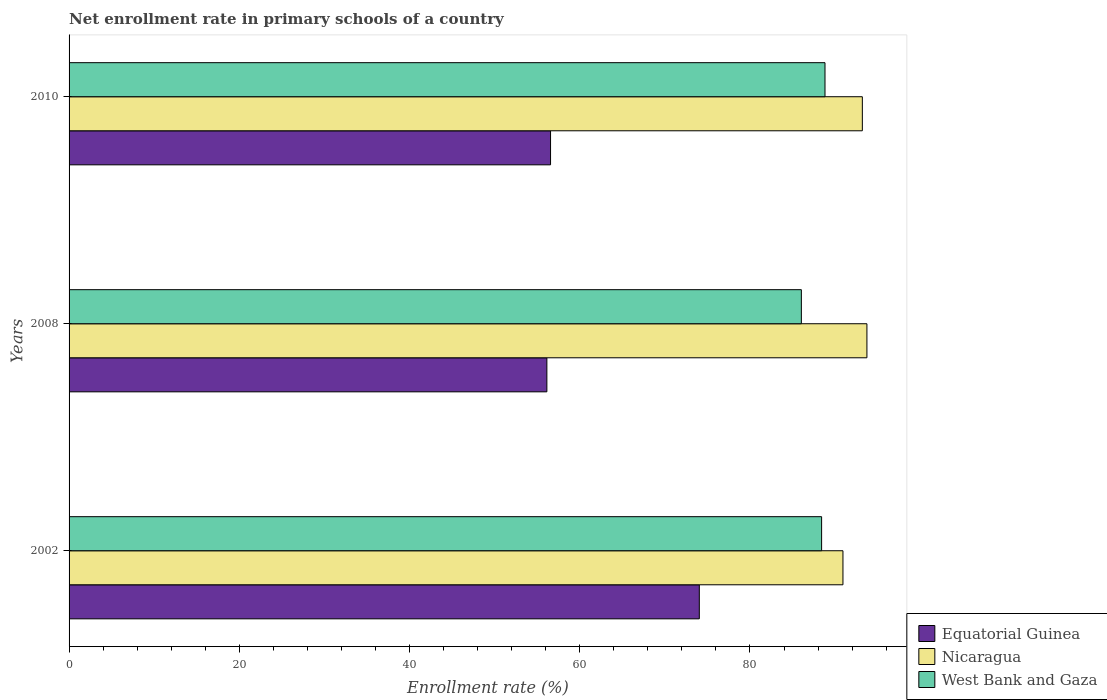How many groups of bars are there?
Keep it short and to the point. 3. How many bars are there on the 1st tick from the bottom?
Your answer should be very brief. 3. What is the enrollment rate in primary schools in Equatorial Guinea in 2010?
Provide a short and direct response. 56.57. Across all years, what is the maximum enrollment rate in primary schools in West Bank and Gaza?
Provide a succinct answer. 88.82. Across all years, what is the minimum enrollment rate in primary schools in Nicaragua?
Make the answer very short. 90.92. What is the total enrollment rate in primary schools in Equatorial Guinea in the graph?
Offer a terse response. 186.75. What is the difference between the enrollment rate in primary schools in Equatorial Guinea in 2002 and that in 2008?
Keep it short and to the point. 17.91. What is the difference between the enrollment rate in primary schools in Equatorial Guinea in 2010 and the enrollment rate in primary schools in Nicaragua in 2008?
Offer a very short reply. -37.17. What is the average enrollment rate in primary schools in Equatorial Guinea per year?
Your answer should be compact. 62.25. In the year 2008, what is the difference between the enrollment rate in primary schools in West Bank and Gaza and enrollment rate in primary schools in Equatorial Guinea?
Offer a very short reply. 29.9. What is the ratio of the enrollment rate in primary schools in Equatorial Guinea in 2002 to that in 2010?
Your answer should be very brief. 1.31. Is the enrollment rate in primary schools in West Bank and Gaza in 2002 less than that in 2008?
Give a very brief answer. No. Is the difference between the enrollment rate in primary schools in West Bank and Gaza in 2002 and 2010 greater than the difference between the enrollment rate in primary schools in Equatorial Guinea in 2002 and 2010?
Give a very brief answer. No. What is the difference between the highest and the second highest enrollment rate in primary schools in Equatorial Guinea?
Provide a short and direct response. 17.48. What is the difference between the highest and the lowest enrollment rate in primary schools in West Bank and Gaza?
Make the answer very short. 2.78. In how many years, is the enrollment rate in primary schools in Equatorial Guinea greater than the average enrollment rate in primary schools in Equatorial Guinea taken over all years?
Your answer should be compact. 1. Is the sum of the enrollment rate in primary schools in Nicaragua in 2002 and 2008 greater than the maximum enrollment rate in primary schools in West Bank and Gaza across all years?
Give a very brief answer. Yes. What does the 2nd bar from the top in 2010 represents?
Keep it short and to the point. Nicaragua. What does the 2nd bar from the bottom in 2002 represents?
Make the answer very short. Nicaragua. Are all the bars in the graph horizontal?
Provide a short and direct response. Yes. How many years are there in the graph?
Provide a succinct answer. 3. What is the difference between two consecutive major ticks on the X-axis?
Provide a succinct answer. 20. Where does the legend appear in the graph?
Keep it short and to the point. Bottom right. What is the title of the graph?
Your response must be concise. Net enrollment rate in primary schools of a country. Does "Romania" appear as one of the legend labels in the graph?
Ensure brevity in your answer.  No. What is the label or title of the X-axis?
Give a very brief answer. Enrollment rate (%). What is the Enrollment rate (%) of Equatorial Guinea in 2002?
Provide a short and direct response. 74.05. What is the Enrollment rate (%) in Nicaragua in 2002?
Offer a terse response. 90.92. What is the Enrollment rate (%) of West Bank and Gaza in 2002?
Make the answer very short. 88.42. What is the Enrollment rate (%) in Equatorial Guinea in 2008?
Keep it short and to the point. 56.14. What is the Enrollment rate (%) in Nicaragua in 2008?
Make the answer very short. 93.74. What is the Enrollment rate (%) of West Bank and Gaza in 2008?
Provide a short and direct response. 86.04. What is the Enrollment rate (%) in Equatorial Guinea in 2010?
Provide a succinct answer. 56.57. What is the Enrollment rate (%) in Nicaragua in 2010?
Give a very brief answer. 93.2. What is the Enrollment rate (%) of West Bank and Gaza in 2010?
Your answer should be very brief. 88.82. Across all years, what is the maximum Enrollment rate (%) in Equatorial Guinea?
Offer a very short reply. 74.05. Across all years, what is the maximum Enrollment rate (%) in Nicaragua?
Give a very brief answer. 93.74. Across all years, what is the maximum Enrollment rate (%) in West Bank and Gaza?
Your answer should be compact. 88.82. Across all years, what is the minimum Enrollment rate (%) in Equatorial Guinea?
Your answer should be compact. 56.14. Across all years, what is the minimum Enrollment rate (%) in Nicaragua?
Offer a terse response. 90.92. Across all years, what is the minimum Enrollment rate (%) in West Bank and Gaza?
Ensure brevity in your answer.  86.04. What is the total Enrollment rate (%) in Equatorial Guinea in the graph?
Your response must be concise. 186.75. What is the total Enrollment rate (%) of Nicaragua in the graph?
Make the answer very short. 277.87. What is the total Enrollment rate (%) in West Bank and Gaza in the graph?
Your response must be concise. 263.27. What is the difference between the Enrollment rate (%) of Equatorial Guinea in 2002 and that in 2008?
Your answer should be very brief. 17.91. What is the difference between the Enrollment rate (%) in Nicaragua in 2002 and that in 2008?
Offer a terse response. -2.82. What is the difference between the Enrollment rate (%) in West Bank and Gaza in 2002 and that in 2008?
Keep it short and to the point. 2.38. What is the difference between the Enrollment rate (%) of Equatorial Guinea in 2002 and that in 2010?
Offer a terse response. 17.48. What is the difference between the Enrollment rate (%) of Nicaragua in 2002 and that in 2010?
Your answer should be compact. -2.28. What is the difference between the Enrollment rate (%) in West Bank and Gaza in 2002 and that in 2010?
Provide a succinct answer. -0.4. What is the difference between the Enrollment rate (%) of Equatorial Guinea in 2008 and that in 2010?
Provide a succinct answer. -0.43. What is the difference between the Enrollment rate (%) of Nicaragua in 2008 and that in 2010?
Provide a short and direct response. 0.54. What is the difference between the Enrollment rate (%) in West Bank and Gaza in 2008 and that in 2010?
Give a very brief answer. -2.78. What is the difference between the Enrollment rate (%) in Equatorial Guinea in 2002 and the Enrollment rate (%) in Nicaragua in 2008?
Keep it short and to the point. -19.69. What is the difference between the Enrollment rate (%) in Equatorial Guinea in 2002 and the Enrollment rate (%) in West Bank and Gaza in 2008?
Your answer should be very brief. -11.99. What is the difference between the Enrollment rate (%) of Nicaragua in 2002 and the Enrollment rate (%) of West Bank and Gaza in 2008?
Provide a short and direct response. 4.89. What is the difference between the Enrollment rate (%) in Equatorial Guinea in 2002 and the Enrollment rate (%) in Nicaragua in 2010?
Ensure brevity in your answer.  -19.15. What is the difference between the Enrollment rate (%) in Equatorial Guinea in 2002 and the Enrollment rate (%) in West Bank and Gaza in 2010?
Your answer should be compact. -14.77. What is the difference between the Enrollment rate (%) of Nicaragua in 2002 and the Enrollment rate (%) of West Bank and Gaza in 2010?
Offer a terse response. 2.11. What is the difference between the Enrollment rate (%) of Equatorial Guinea in 2008 and the Enrollment rate (%) of Nicaragua in 2010?
Your answer should be compact. -37.06. What is the difference between the Enrollment rate (%) in Equatorial Guinea in 2008 and the Enrollment rate (%) in West Bank and Gaza in 2010?
Offer a terse response. -32.68. What is the difference between the Enrollment rate (%) of Nicaragua in 2008 and the Enrollment rate (%) of West Bank and Gaza in 2010?
Keep it short and to the point. 4.93. What is the average Enrollment rate (%) in Equatorial Guinea per year?
Your answer should be compact. 62.25. What is the average Enrollment rate (%) in Nicaragua per year?
Your answer should be compact. 92.62. What is the average Enrollment rate (%) of West Bank and Gaza per year?
Ensure brevity in your answer.  87.76. In the year 2002, what is the difference between the Enrollment rate (%) of Equatorial Guinea and Enrollment rate (%) of Nicaragua?
Offer a terse response. -16.88. In the year 2002, what is the difference between the Enrollment rate (%) of Equatorial Guinea and Enrollment rate (%) of West Bank and Gaza?
Your answer should be compact. -14.37. In the year 2002, what is the difference between the Enrollment rate (%) of Nicaragua and Enrollment rate (%) of West Bank and Gaza?
Offer a very short reply. 2.51. In the year 2008, what is the difference between the Enrollment rate (%) in Equatorial Guinea and Enrollment rate (%) in Nicaragua?
Ensure brevity in your answer.  -37.6. In the year 2008, what is the difference between the Enrollment rate (%) of Equatorial Guinea and Enrollment rate (%) of West Bank and Gaza?
Provide a short and direct response. -29.9. In the year 2008, what is the difference between the Enrollment rate (%) in Nicaragua and Enrollment rate (%) in West Bank and Gaza?
Make the answer very short. 7.7. In the year 2010, what is the difference between the Enrollment rate (%) in Equatorial Guinea and Enrollment rate (%) in Nicaragua?
Your answer should be compact. -36.63. In the year 2010, what is the difference between the Enrollment rate (%) of Equatorial Guinea and Enrollment rate (%) of West Bank and Gaza?
Offer a terse response. -32.25. In the year 2010, what is the difference between the Enrollment rate (%) in Nicaragua and Enrollment rate (%) in West Bank and Gaza?
Keep it short and to the point. 4.39. What is the ratio of the Enrollment rate (%) in Equatorial Guinea in 2002 to that in 2008?
Your answer should be very brief. 1.32. What is the ratio of the Enrollment rate (%) of Nicaragua in 2002 to that in 2008?
Keep it short and to the point. 0.97. What is the ratio of the Enrollment rate (%) of West Bank and Gaza in 2002 to that in 2008?
Make the answer very short. 1.03. What is the ratio of the Enrollment rate (%) in Equatorial Guinea in 2002 to that in 2010?
Your answer should be compact. 1.31. What is the ratio of the Enrollment rate (%) in Nicaragua in 2002 to that in 2010?
Your answer should be very brief. 0.98. What is the ratio of the Enrollment rate (%) of West Bank and Gaza in 2002 to that in 2010?
Your answer should be very brief. 1. What is the ratio of the Enrollment rate (%) in Equatorial Guinea in 2008 to that in 2010?
Offer a terse response. 0.99. What is the ratio of the Enrollment rate (%) of West Bank and Gaza in 2008 to that in 2010?
Give a very brief answer. 0.97. What is the difference between the highest and the second highest Enrollment rate (%) of Equatorial Guinea?
Provide a succinct answer. 17.48. What is the difference between the highest and the second highest Enrollment rate (%) in Nicaragua?
Give a very brief answer. 0.54. What is the difference between the highest and the second highest Enrollment rate (%) of West Bank and Gaza?
Ensure brevity in your answer.  0.4. What is the difference between the highest and the lowest Enrollment rate (%) in Equatorial Guinea?
Keep it short and to the point. 17.91. What is the difference between the highest and the lowest Enrollment rate (%) in Nicaragua?
Offer a terse response. 2.82. What is the difference between the highest and the lowest Enrollment rate (%) of West Bank and Gaza?
Provide a short and direct response. 2.78. 